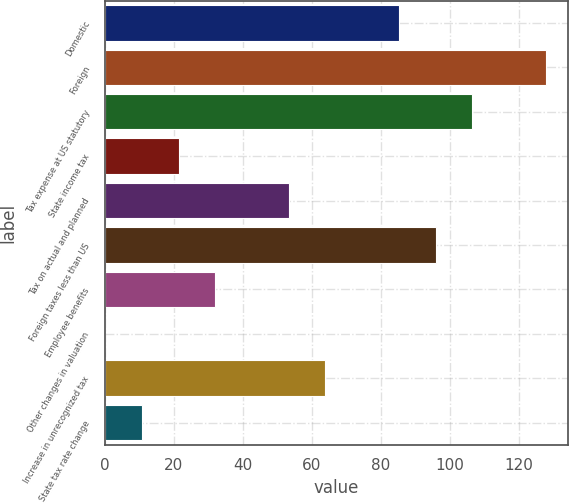Convert chart to OTSL. <chart><loc_0><loc_0><loc_500><loc_500><bar_chart><fcel>Domestic<fcel>Foreign<fcel>Tax expense at US statutory<fcel>State income tax<fcel>Tax on actual and planned<fcel>Foreign taxes less than US<fcel>Employee benefits<fcel>Other changes in valuation<fcel>Increase in unrecognized tax<fcel>State tax rate change<nl><fcel>85.3<fcel>127.9<fcel>106.6<fcel>21.4<fcel>53.35<fcel>95.95<fcel>32.05<fcel>0.1<fcel>64<fcel>10.75<nl></chart> 